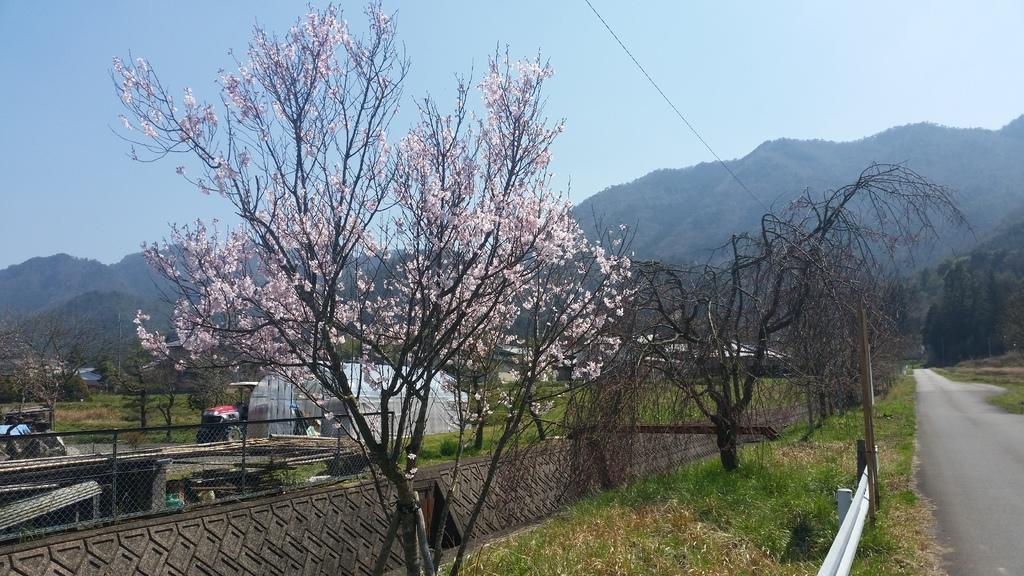How would you summarize this image in a sentence or two? In this picture there are trees and mountains. On the right side of the image there are buildings and there is a shed behind the fence. On the right side of the image there is a railing and there is a road. At the top there is sky. At the bottom there is a road and there is grass. In the foreground there are light pink color flowers on the tree. 